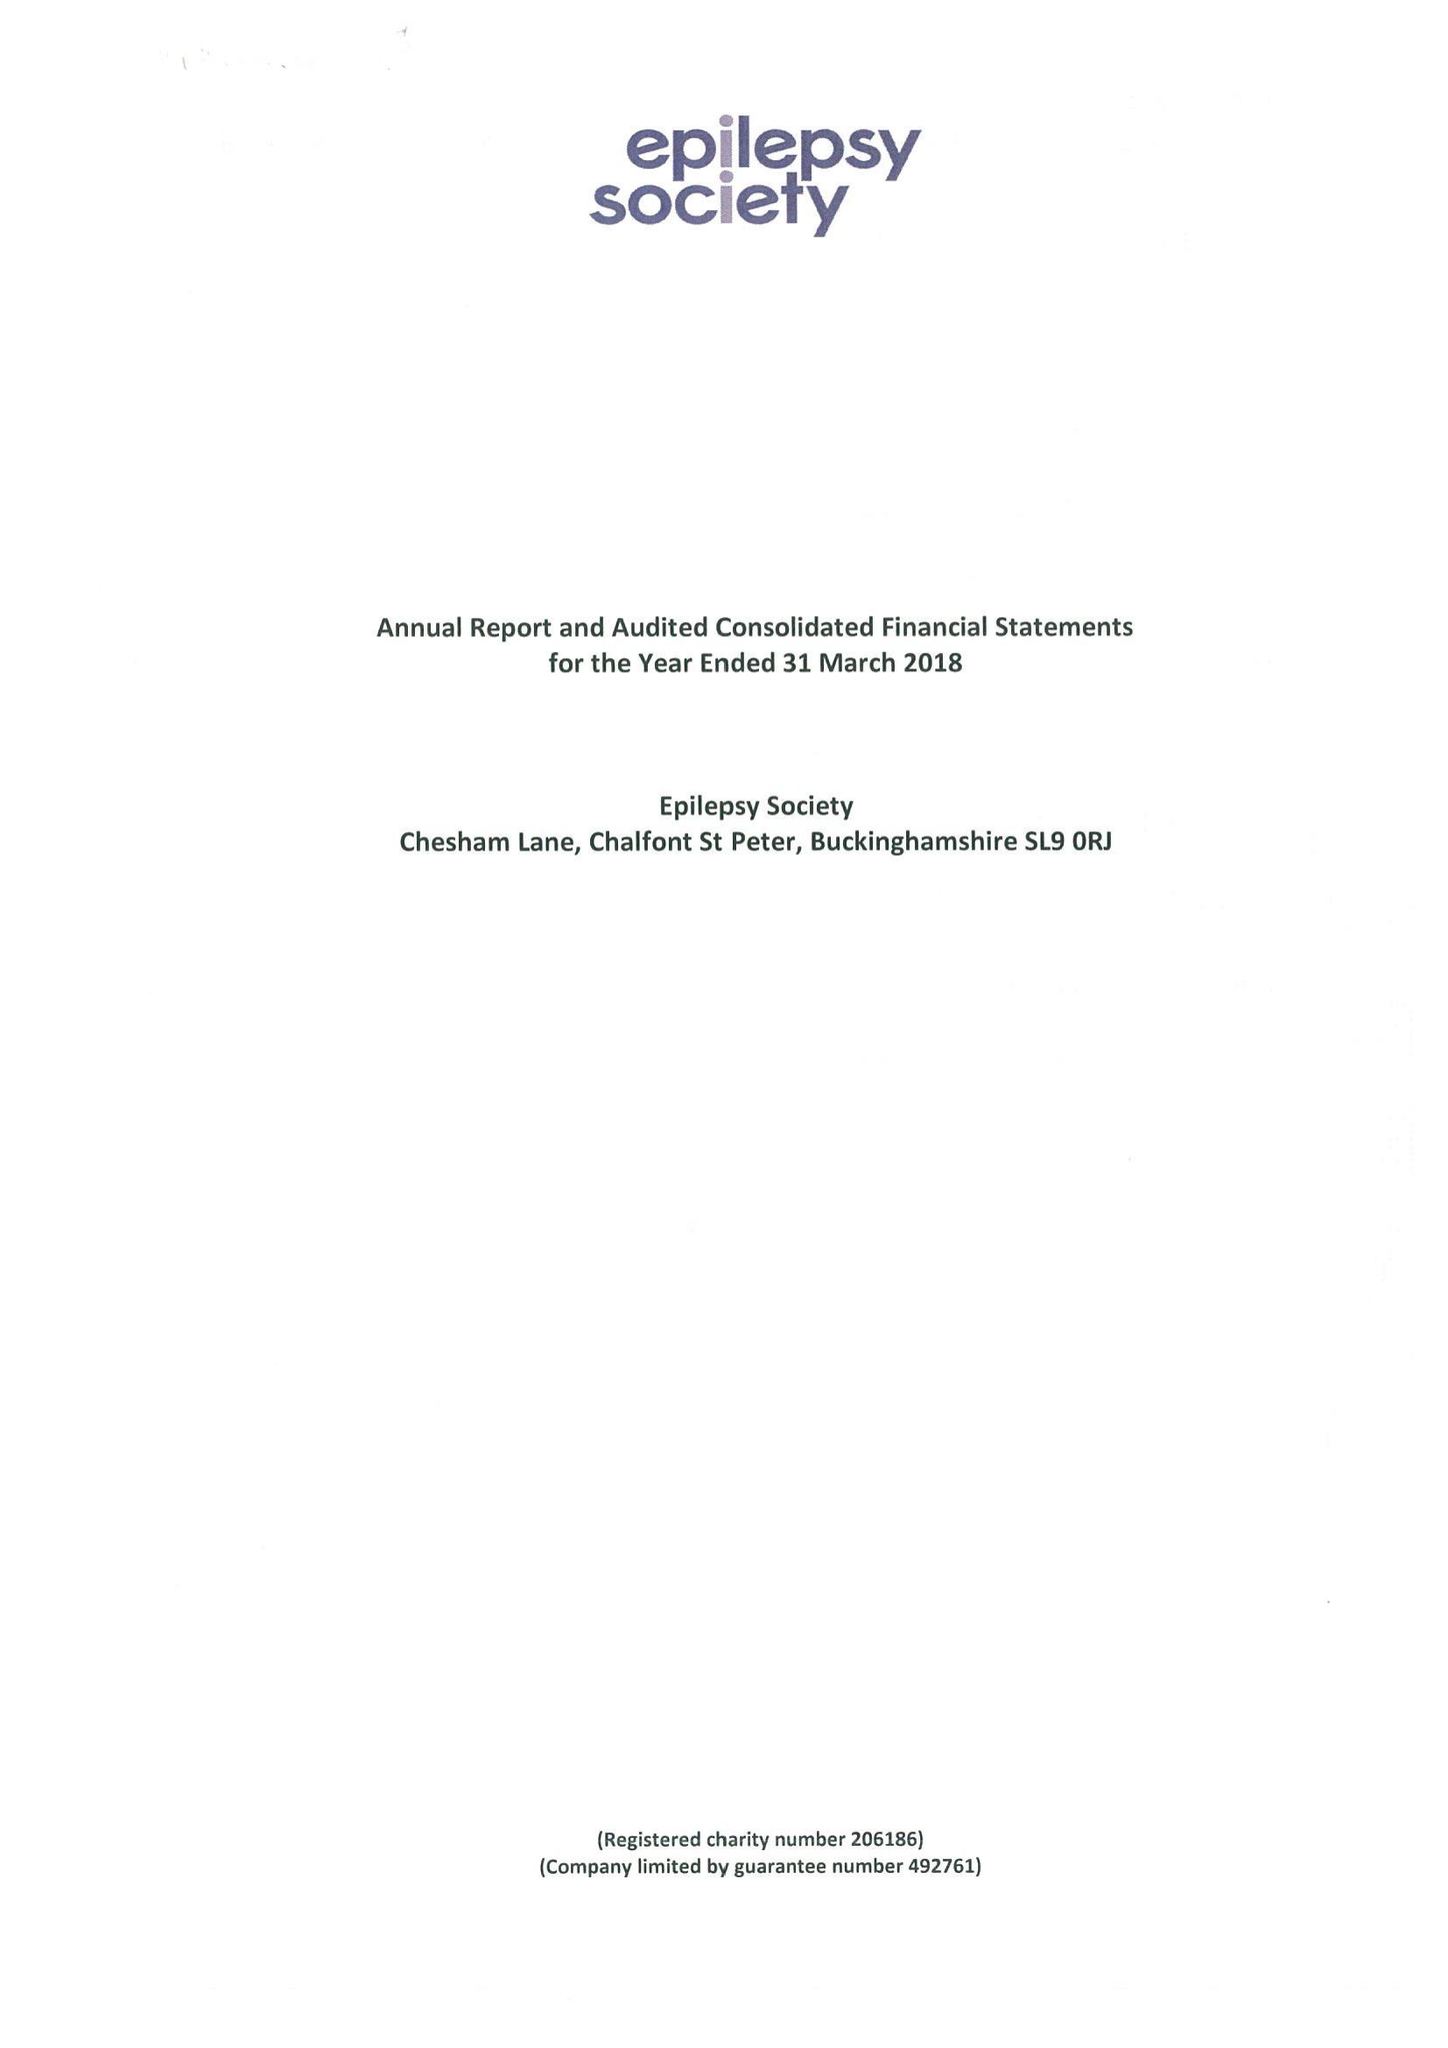What is the value for the address__street_line?
Answer the question using a single word or phrase. CHESHAM LANE 